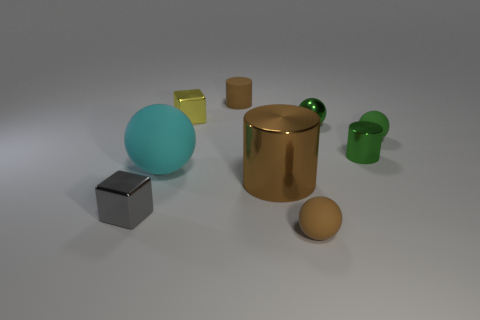The metallic thing that is the same size as the cyan sphere is what shape?
Your answer should be compact. Cylinder. What size is the cyan matte object behind the tiny gray object?
Your response must be concise. Large. There is a tiny matte thing on the right side of the brown sphere; does it have the same color as the shiny cylinder that is behind the large cyan matte object?
Your answer should be compact. Yes. There is a brown object that is behind the tiny rubber sphere right of the tiny ball in front of the brown metallic cylinder; what is it made of?
Offer a terse response. Rubber. Are there any other cyan matte cylinders that have the same size as the rubber cylinder?
Your answer should be very brief. No. There is a brown ball that is the same size as the yellow object; what is it made of?
Offer a very short reply. Rubber. The matte object that is on the right side of the small brown ball has what shape?
Offer a very short reply. Sphere. Are the ball that is on the left side of the brown rubber ball and the block that is behind the tiny gray metal block made of the same material?
Give a very brief answer. No. How many other metallic things are the same shape as the tiny yellow metallic thing?
Your answer should be compact. 1. There is a small thing that is the same color as the tiny matte cylinder; what material is it?
Ensure brevity in your answer.  Rubber. 